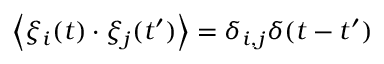<formula> <loc_0><loc_0><loc_500><loc_500>\left < { \xi _ { i } ( t ) \cdot \xi _ { j } ( t ^ { \prime } ) } \right > = \delta _ { i , j } \delta ( t - t ^ { \prime } )</formula> 